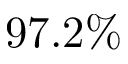<formula> <loc_0><loc_0><loc_500><loc_500>9 7 . 2 \%</formula> 